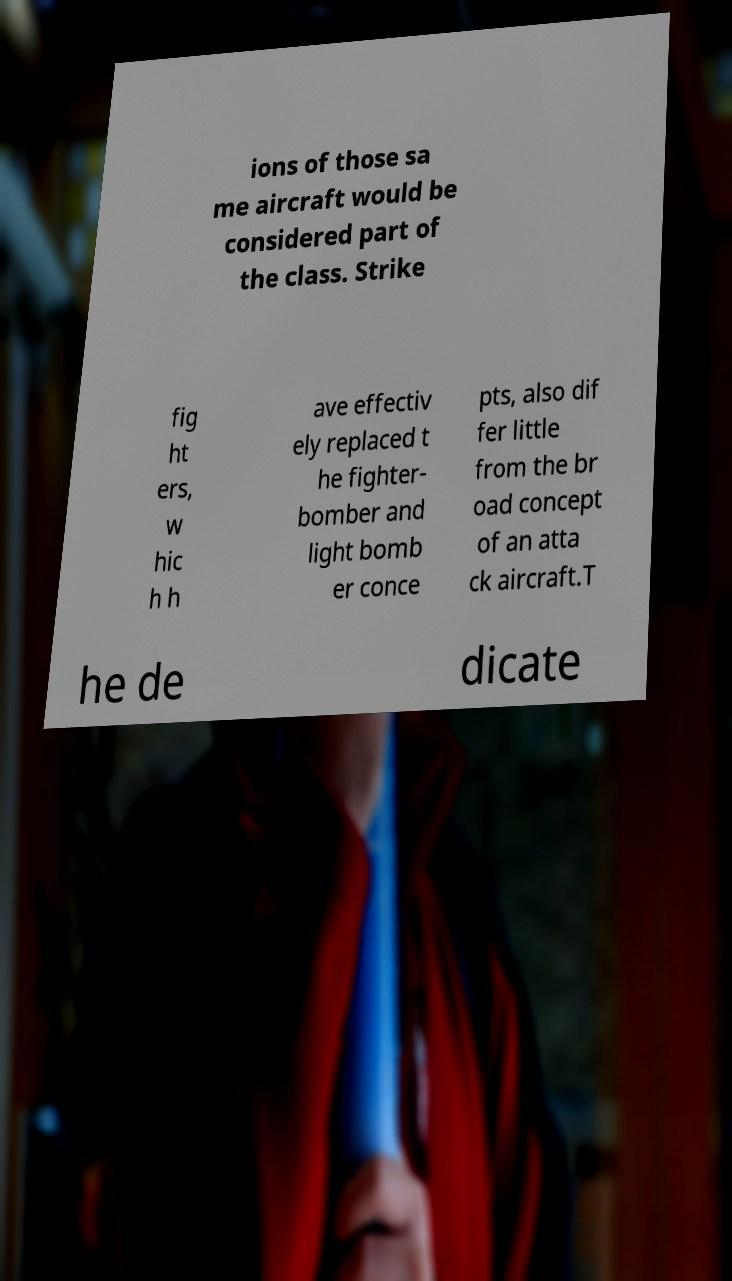Could you assist in decoding the text presented in this image and type it out clearly? ions of those sa me aircraft would be considered part of the class. Strike fig ht ers, w hic h h ave effectiv ely replaced t he fighter- bomber and light bomb er conce pts, also dif fer little from the br oad concept of an atta ck aircraft.T he de dicate 